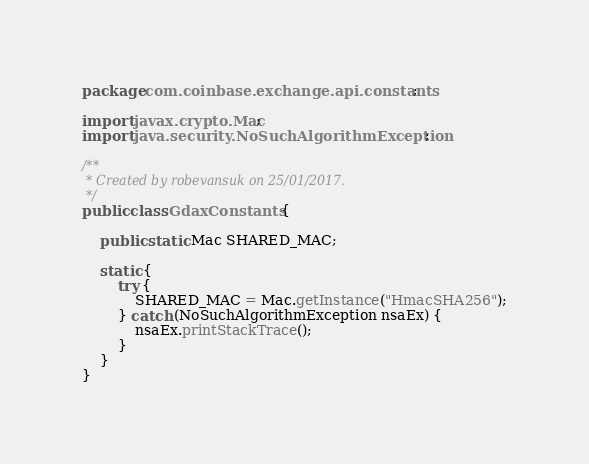<code> <loc_0><loc_0><loc_500><loc_500><_Java_>package com.coinbase.exchange.api.constants;

import javax.crypto.Mac;
import java.security.NoSuchAlgorithmException;

/**
 * Created by robevansuk on 25/01/2017.
 */
public class GdaxConstants {

    public static Mac SHARED_MAC;

    static {
        try {
            SHARED_MAC = Mac.getInstance("HmacSHA256");
        } catch (NoSuchAlgorithmException nsaEx) {
            nsaEx.printStackTrace();
        }
    }
}
</code> 